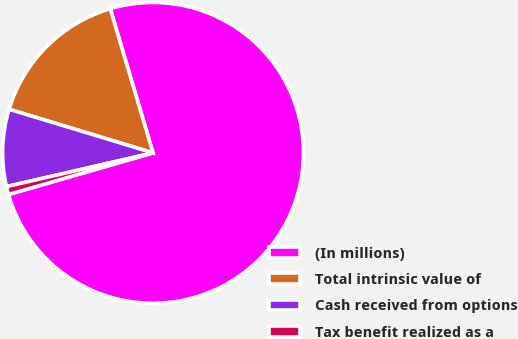<chart> <loc_0><loc_0><loc_500><loc_500><pie_chart><fcel>(In millions)<fcel>Total intrinsic value of<fcel>Cash received from options<fcel>Tax benefit realized as a<nl><fcel>75.14%<fcel>15.72%<fcel>8.29%<fcel>0.86%<nl></chart> 